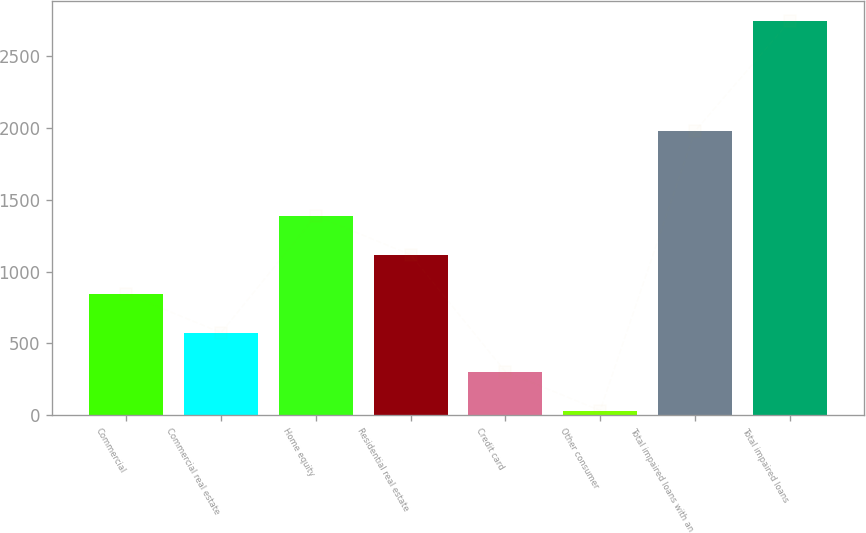Convert chart to OTSL. <chart><loc_0><loc_0><loc_500><loc_500><bar_chart><fcel>Commercial<fcel>Commercial real estate<fcel>Home equity<fcel>Residential real estate<fcel>Credit card<fcel>Other consumer<fcel>Total impaired loans with an<fcel>Total impaired loans<nl><fcel>845.6<fcel>574.4<fcel>1388<fcel>1116.8<fcel>303.2<fcel>32<fcel>1977<fcel>2744<nl></chart> 